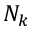Convert formula to latex. <formula><loc_0><loc_0><loc_500><loc_500>N _ { k }</formula> 